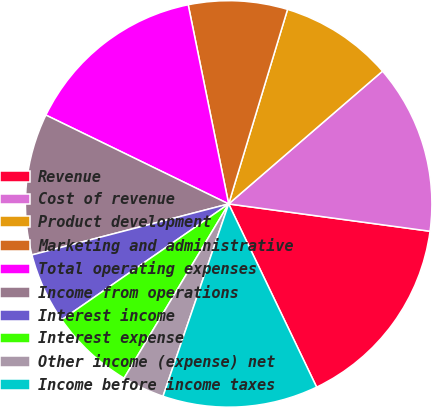Convert chart. <chart><loc_0><loc_0><loc_500><loc_500><pie_chart><fcel>Revenue<fcel>Cost of revenue<fcel>Product development<fcel>Marketing and administrative<fcel>Total operating expenses<fcel>Income from operations<fcel>Interest income<fcel>Interest expense<fcel>Other income (expense) net<fcel>Income before income taxes<nl><fcel>15.73%<fcel>13.48%<fcel>8.99%<fcel>7.87%<fcel>14.61%<fcel>11.24%<fcel>5.62%<fcel>6.74%<fcel>3.37%<fcel>12.36%<nl></chart> 